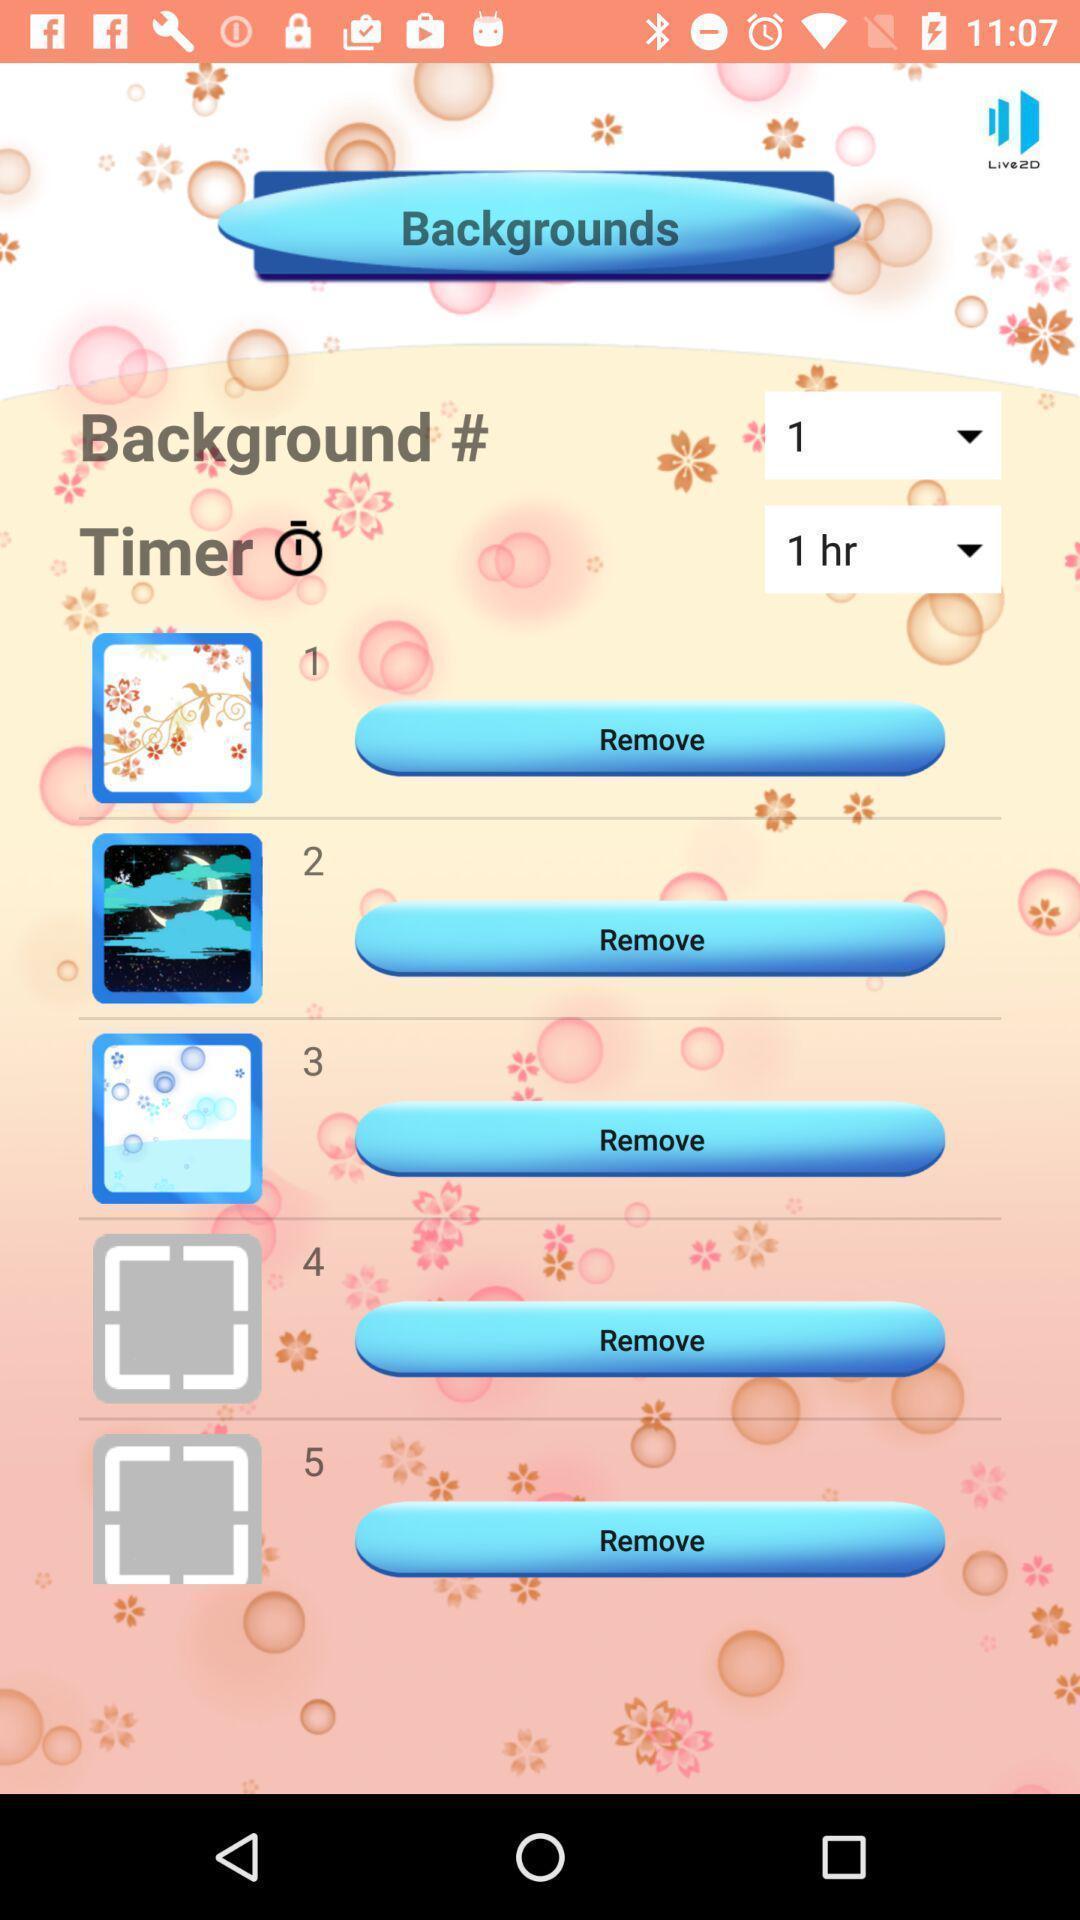Tell me about the visual elements in this screen capture. Page showing options related to a theme setting app. 